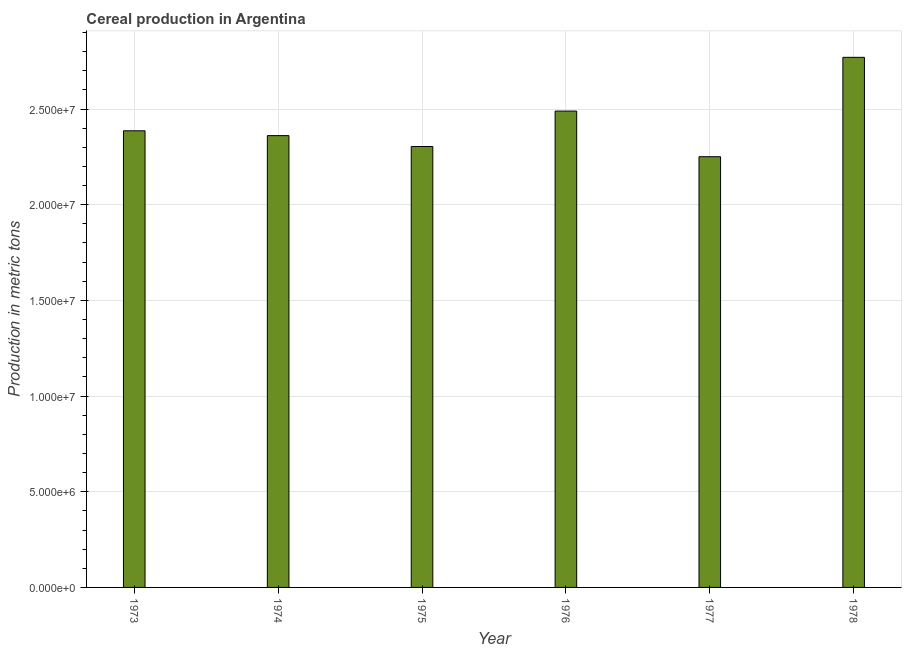Does the graph contain any zero values?
Offer a terse response. No. Does the graph contain grids?
Offer a terse response. Yes. What is the title of the graph?
Your answer should be compact. Cereal production in Argentina. What is the label or title of the X-axis?
Your response must be concise. Year. What is the label or title of the Y-axis?
Make the answer very short. Production in metric tons. What is the cereal production in 1976?
Give a very brief answer. 2.49e+07. Across all years, what is the maximum cereal production?
Provide a succinct answer. 2.77e+07. Across all years, what is the minimum cereal production?
Offer a very short reply. 2.25e+07. In which year was the cereal production maximum?
Make the answer very short. 1978. In which year was the cereal production minimum?
Give a very brief answer. 1977. What is the sum of the cereal production?
Your response must be concise. 1.46e+08. What is the difference between the cereal production in 1974 and 1975?
Offer a very short reply. 5.68e+05. What is the average cereal production per year?
Offer a terse response. 2.43e+07. What is the median cereal production?
Offer a terse response. 2.37e+07. Is the difference between the cereal production in 1975 and 1977 greater than the difference between any two years?
Your response must be concise. No. What is the difference between the highest and the second highest cereal production?
Your answer should be very brief. 2.81e+06. What is the difference between the highest and the lowest cereal production?
Make the answer very short. 5.19e+06. How many years are there in the graph?
Your response must be concise. 6. What is the difference between two consecutive major ticks on the Y-axis?
Provide a succinct answer. 5.00e+06. What is the Production in metric tons in 1973?
Give a very brief answer. 2.39e+07. What is the Production in metric tons of 1974?
Offer a terse response. 2.36e+07. What is the Production in metric tons in 1975?
Provide a succinct answer. 2.30e+07. What is the Production in metric tons of 1976?
Ensure brevity in your answer.  2.49e+07. What is the Production in metric tons in 1977?
Provide a succinct answer. 2.25e+07. What is the Production in metric tons in 1978?
Make the answer very short. 2.77e+07. What is the difference between the Production in metric tons in 1973 and 1974?
Offer a terse response. 2.52e+05. What is the difference between the Production in metric tons in 1973 and 1975?
Give a very brief answer. 8.20e+05. What is the difference between the Production in metric tons in 1973 and 1976?
Keep it short and to the point. -1.03e+06. What is the difference between the Production in metric tons in 1973 and 1977?
Keep it short and to the point. 1.35e+06. What is the difference between the Production in metric tons in 1973 and 1978?
Offer a very short reply. -3.84e+06. What is the difference between the Production in metric tons in 1974 and 1975?
Provide a short and direct response. 5.68e+05. What is the difference between the Production in metric tons in 1974 and 1976?
Your response must be concise. -1.28e+06. What is the difference between the Production in metric tons in 1974 and 1977?
Your answer should be compact. 1.10e+06. What is the difference between the Production in metric tons in 1974 and 1978?
Your answer should be compact. -4.09e+06. What is the difference between the Production in metric tons in 1975 and 1976?
Offer a very short reply. -1.85e+06. What is the difference between the Production in metric tons in 1975 and 1977?
Offer a terse response. 5.34e+05. What is the difference between the Production in metric tons in 1975 and 1978?
Your response must be concise. -4.66e+06. What is the difference between the Production in metric tons in 1976 and 1977?
Offer a very short reply. 2.38e+06. What is the difference between the Production in metric tons in 1976 and 1978?
Provide a succinct answer. -2.81e+06. What is the difference between the Production in metric tons in 1977 and 1978?
Ensure brevity in your answer.  -5.19e+06. What is the ratio of the Production in metric tons in 1973 to that in 1974?
Provide a short and direct response. 1.01. What is the ratio of the Production in metric tons in 1973 to that in 1975?
Provide a short and direct response. 1.04. What is the ratio of the Production in metric tons in 1973 to that in 1976?
Give a very brief answer. 0.96. What is the ratio of the Production in metric tons in 1973 to that in 1977?
Make the answer very short. 1.06. What is the ratio of the Production in metric tons in 1973 to that in 1978?
Your response must be concise. 0.86. What is the ratio of the Production in metric tons in 1974 to that in 1975?
Provide a short and direct response. 1.02. What is the ratio of the Production in metric tons in 1974 to that in 1976?
Keep it short and to the point. 0.95. What is the ratio of the Production in metric tons in 1974 to that in 1977?
Your response must be concise. 1.05. What is the ratio of the Production in metric tons in 1974 to that in 1978?
Your response must be concise. 0.85. What is the ratio of the Production in metric tons in 1975 to that in 1976?
Your answer should be compact. 0.93. What is the ratio of the Production in metric tons in 1975 to that in 1977?
Your answer should be compact. 1.02. What is the ratio of the Production in metric tons in 1975 to that in 1978?
Make the answer very short. 0.83. What is the ratio of the Production in metric tons in 1976 to that in 1977?
Your answer should be compact. 1.11. What is the ratio of the Production in metric tons in 1976 to that in 1978?
Offer a very short reply. 0.9. What is the ratio of the Production in metric tons in 1977 to that in 1978?
Offer a terse response. 0.81. 